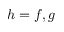<formula> <loc_0><loc_0><loc_500><loc_500>h = f , g</formula> 